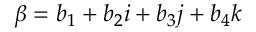<formula> <loc_0><loc_0><loc_500><loc_500>\beta = b _ { 1 } + b _ { 2 } i + b _ { 3 } j + b _ { 4 } k</formula> 